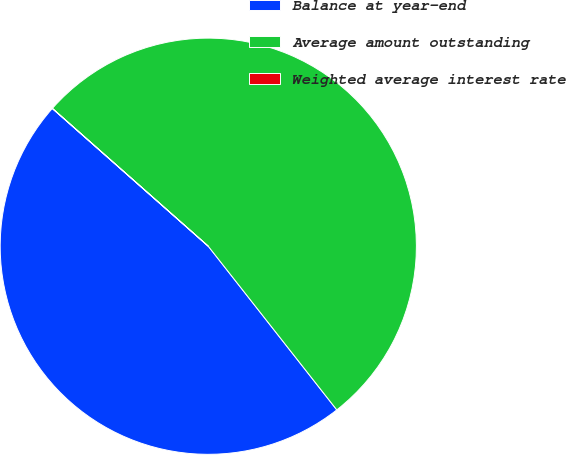Convert chart. <chart><loc_0><loc_0><loc_500><loc_500><pie_chart><fcel>Balance at year-end<fcel>Average amount outstanding<fcel>Weighted average interest rate<nl><fcel>47.11%<fcel>52.88%<fcel>0.01%<nl></chart> 